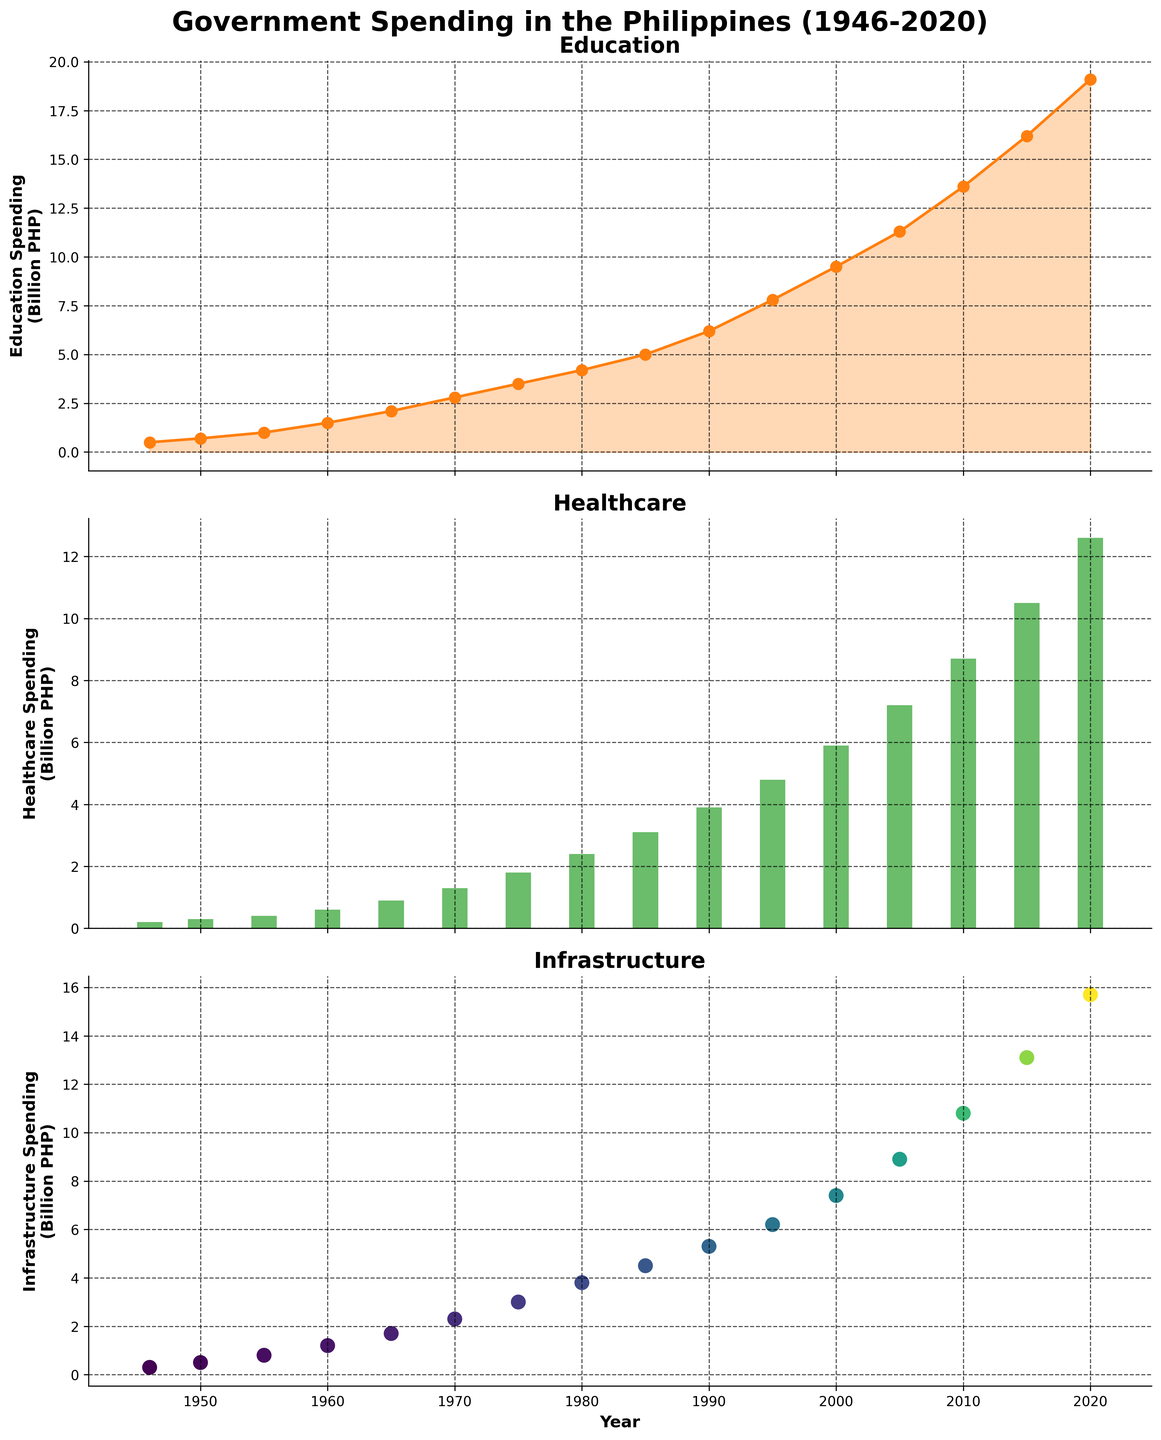what trend is observed in government spending on education from 1946 to 2020? Observing the line plot of education spending, there is a consistent upward trend from 1946 to 2020. Initially starting at 0.5 billion PHP in 1946, it increases steadily, reaching 19.1 billion PHP by 2020.
Answer: The trend is consistently upward What year saw the highest spending on healthcare? Checking the bar plot of healthcare spending, the height of the bars reveals that 2020 experienced the highest spending. By locating the tallest bar visually, it corresponds to 2020.
Answer: 2020 How does the spending on infrastructure in 1985 compare to 2000? Referring to the scatter plot for infrastructure spending, the 1985 dot is around 4.5 billion PHP. Meanwhile, the dot for 2000 is higher at around 7.4 billion PHP. Therefore, the spending in 2000 is greater than in 1985.
Answer: Spending in 2000 is higher than in 1985 What is the sum of education, healthcare, and infrastructure spending for the year 1960? From the respective plots, education spending in 1960 is 1.5 billion PHP, healthcare spending is 0.6 billion PHP, and infrastructure spending is 1.2 billion PHP. Adding these together: 1.5 + 0.6 + 1.2 = 3.3 billion PHP.
Answer: 3.3 billion PHP Did healthcare spending surpass 10 billion PHP before 2015? By inspecting the bar plot, we observe that the healthcare spending bar does not surpass 10 billion PHP until the 2015 mark.
Answer: No Which type of spending saw the largest relative increase from 1946 to 2020? Calculating the relative increases: 
- For education: (19.1 - 0.5) / 0.5 = 37.2 times
- For healthcare: (12.6 - 0.2) / 0.2 = 62 times
- For infrastructure: (15.7 - 0.3) / 0.3 = 51.33 times
Healthcare has the largest relative increase.
Answer: Healthcare What is the difference in healthcare spending between 1970 and 2000? From the bar plot, in 1970 the healthcare spending is 1.3 billion PHP, and in 2000 it is 5.9 billion PHP. Subtracting these: 5.9 - 1.3 = 4.6 billion PHP.
Answer: 4.6 billion PHP By how much did education spending increase between 1990 and 2020? Checking the line plot, education spending in 1990 is 6.2 billion PHP and in 2020 is 19.1 billion PHP. Subtracting these figures: 19.1 - 6.2 = 12.9 billion PHP.
Answer: 12.9 billion PHP 